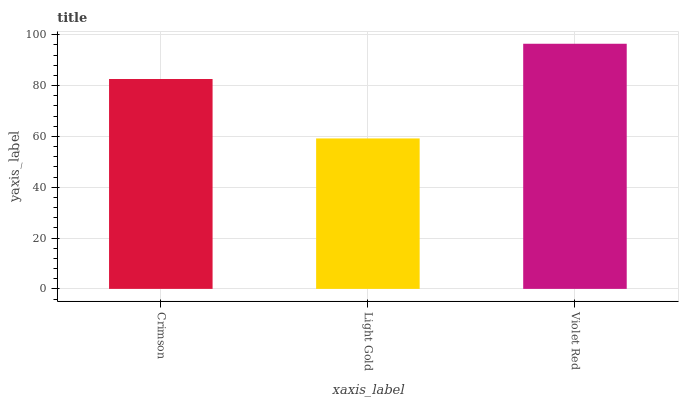Is Light Gold the minimum?
Answer yes or no. Yes. Is Violet Red the maximum?
Answer yes or no. Yes. Is Violet Red the minimum?
Answer yes or no. No. Is Light Gold the maximum?
Answer yes or no. No. Is Violet Red greater than Light Gold?
Answer yes or no. Yes. Is Light Gold less than Violet Red?
Answer yes or no. Yes. Is Light Gold greater than Violet Red?
Answer yes or no. No. Is Violet Red less than Light Gold?
Answer yes or no. No. Is Crimson the high median?
Answer yes or no. Yes. Is Crimson the low median?
Answer yes or no. Yes. Is Light Gold the high median?
Answer yes or no. No. Is Light Gold the low median?
Answer yes or no. No. 